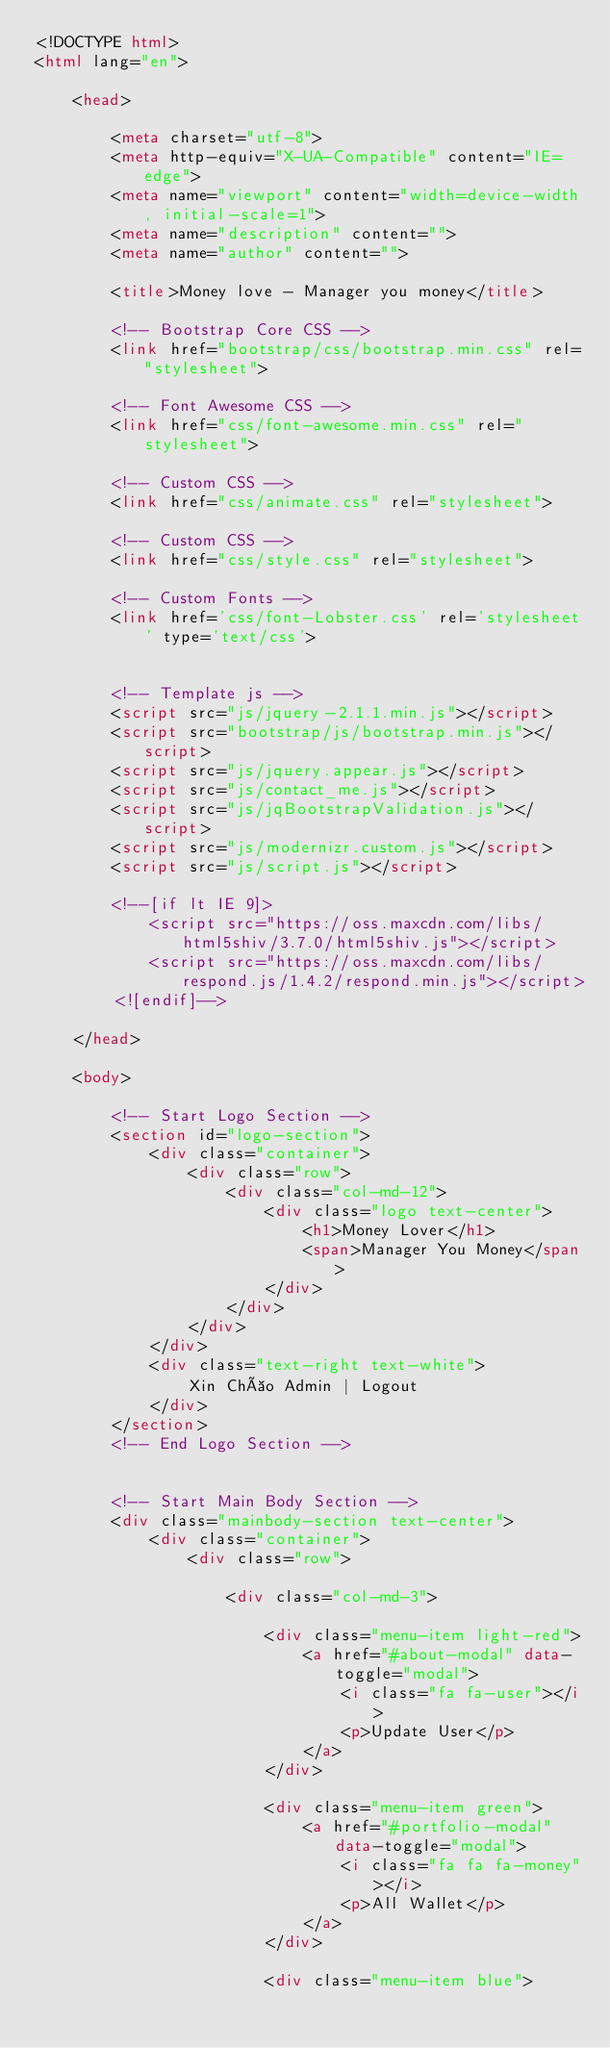Convert code to text. <code><loc_0><loc_0><loc_500><loc_500><_HTML_><!DOCTYPE html>
<html lang="en">

    <head>

        <meta charset="utf-8">
        <meta http-equiv="X-UA-Compatible" content="IE=edge">
        <meta name="viewport" content="width=device-width, initial-scale=1">
        <meta name="description" content="">
        <meta name="author" content="">

        <title>Money love - Manager you money</title>

        <!-- Bootstrap Core CSS -->
        <link href="bootstrap/css/bootstrap.min.css" rel="stylesheet">

        <!-- Font Awesome CSS -->
        <link href="css/font-awesome.min.css" rel="stylesheet">
        
        <!-- Custom CSS -->
        <link href="css/animate.css" rel="stylesheet">

        <!-- Custom CSS -->
        <link href="css/style.css" rel="stylesheet">

        <!-- Custom Fonts -->
        <link href='css/font-Lobster.css' rel='stylesheet' type='text/css'>


        <!-- Template js -->
        <script src="js/jquery-2.1.1.min.js"></script>
        <script src="bootstrap/js/bootstrap.min.js"></script>
        <script src="js/jquery.appear.js"></script>
        <script src="js/contact_me.js"></script>
        <script src="js/jqBootstrapValidation.js"></script>
        <script src="js/modernizr.custom.js"></script>
        <script src="js/script.js"></script>

        <!--[if lt IE 9]>
            <script src="https://oss.maxcdn.com/libs/html5shiv/3.7.0/html5shiv.js"></script>
            <script src="https://oss.maxcdn.com/libs/respond.js/1.4.2/respond.min.js"></script>
        <![endif]-->

    </head>
    
    <body>
        
        <!-- Start Logo Section -->
        <section id="logo-section">
            <div class="container">
                <div class="row">
                    <div class="col-md-12">
                        <div class="logo text-center">
                            <h1>Money Lover</h1>
                            <span>Manager You Money</span>
                        </div>
                    </div>
                </div>
            </div>
            <div class="text-right text-white">
                Xin Chào Admin | Logout
            </div>
        </section>
        <!-- End Logo Section -->
        
        
        <!-- Start Main Body Section -->
        <div class="mainbody-section text-center">
            <div class="container">
                <div class="row">
                    
                    <div class="col-md-3">
                        
                        <div class="menu-item light-red">
                            <a href="#about-modal" data-toggle="modal">
                                <i class="fa fa-user"></i>
                                <p>Update User</p>
                            </a>
                        </div>
                        
                        <div class="menu-item green">
                            <a href="#portfolio-modal" data-toggle="modal">
                                <i class="fa fa fa-money"></i>
                                <p>All Wallet</p>
                            </a>
                        </div>
                        
                        <div class="menu-item blue"></code> 